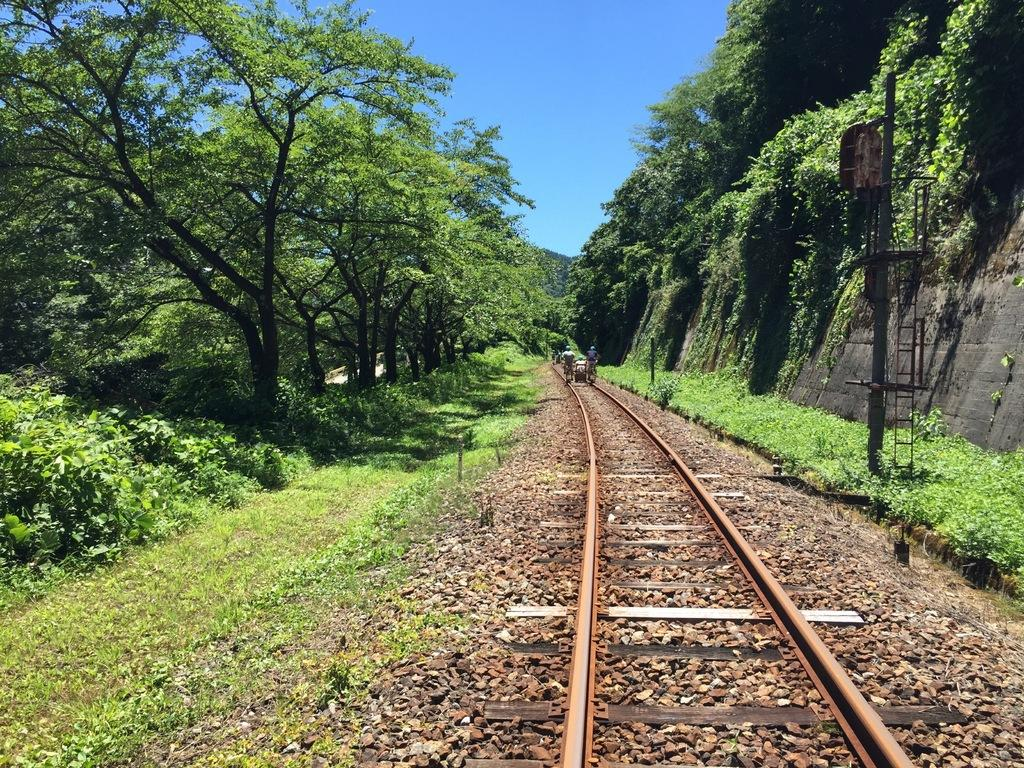How many people are in the image? There are two persons in the image. What are the persons doing in the image? The persons are standing on a railway track. What can be seen in the background of the image? There is a pole, a group of trees, and the sky visible in the background of the image. What type of dinner is being prepared by the fireman in the image? There is no fireman or dinner preparation present in the image. How does the beginner feel about their first time on the railway track in the image? There is no indication of the persons' experience level or emotions in the image. 